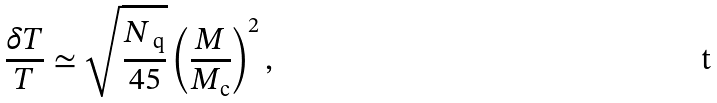<formula> <loc_0><loc_0><loc_500><loc_500>\frac { \delta T } { T } \simeq \sqrt { \frac { N _ { \text { q} } } { 4 5 } } \left ( \frac { M } { M _ { \text {c} } } \right ) ^ { 2 } ,</formula> 